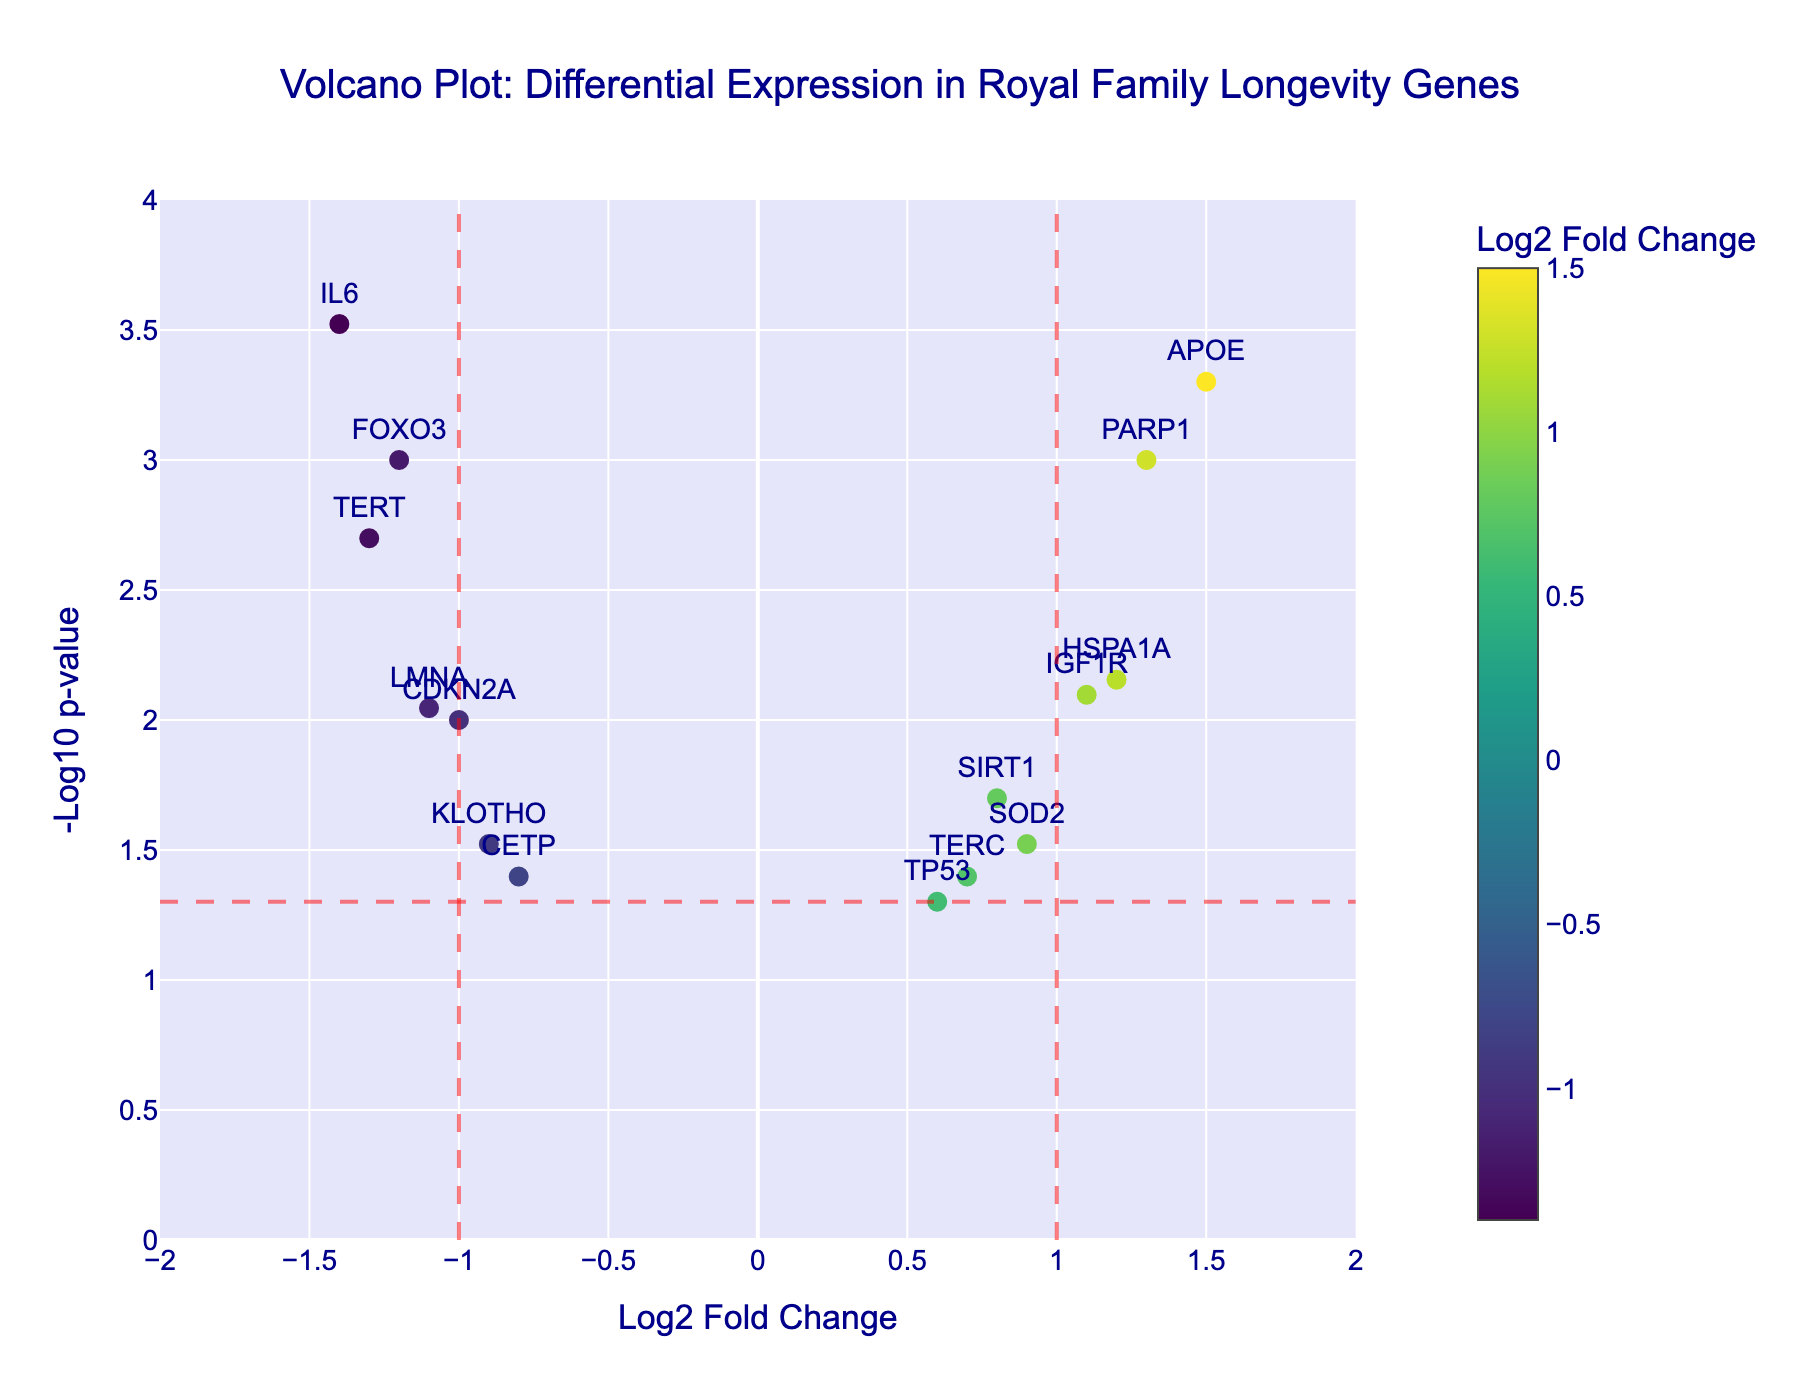What is the title of the plot? The title is displayed at the top center of the plot within a large dark blue font.
Answer: "Volcano Plot: Differential Expression in Royal Family Longevity Genes" What gene has the highest -log10 p-value? To determine this, we look for the gene positioned highest on the y-axis.
Answer: IL6 Which gene shows the highest positive log2 fold change? Identify the gene farthest to the right on the x-axis.
Answer: APOE What are the thresholds indicated by the red dashed lines for log2 fold change and -log10 p-value? The vertical dashed lines represent the thresholds for log2 fold change at ±1, and the horizontal dashed line represents the -log10 p value threshold at 1.3.
Answer: ±1, 1.3 What genes fall into the significant upregulated category? Significant upregulated genes are above the horizontal line and to the right of the vertical line at x=1.
Answer: APOE, IGF1R, HSPA1A, PARP1 How many genes have a negative log2 fold change but are still significant? Find the genes that are left of the x=0 and above the y-axis threshold at 1.3.
Answer: 3 (IL6, TERT, FOXO3) Compare the log2 fold changes of the genes SIRT1 and CDKN2A. Which is higher? Locate both genes on the x-axis and compare their positions.
Answer: SIRT1 Which gene has close to no change in expression but still crosses the p-value threshold? A gene near x=0 and above the y-axis threshold of 1.3.
Answer: TP53 What is the log2 fold change and p-value of the gene LMNA? Hovering over the gene on the volcano plot provides details, specifically its log2 fold change and p-value.
Answer: -1.1, 0.009 Which gene shows significant downregulation? Identify any gene positioned to the far left of the plot below the threshold lines.
Answer: IL6 